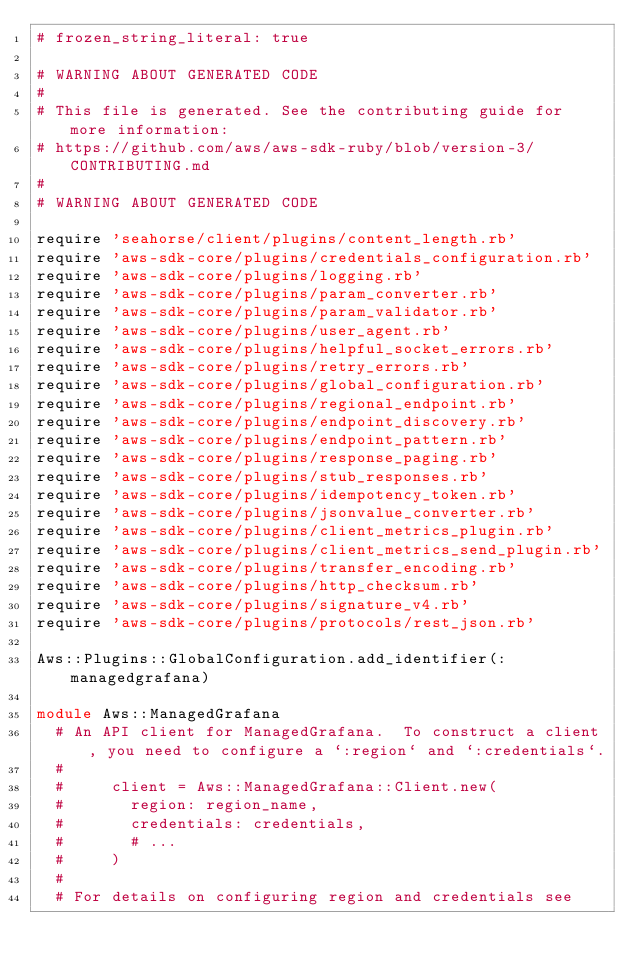Convert code to text. <code><loc_0><loc_0><loc_500><loc_500><_Ruby_># frozen_string_literal: true

# WARNING ABOUT GENERATED CODE
#
# This file is generated. See the contributing guide for more information:
# https://github.com/aws/aws-sdk-ruby/blob/version-3/CONTRIBUTING.md
#
# WARNING ABOUT GENERATED CODE

require 'seahorse/client/plugins/content_length.rb'
require 'aws-sdk-core/plugins/credentials_configuration.rb'
require 'aws-sdk-core/plugins/logging.rb'
require 'aws-sdk-core/plugins/param_converter.rb'
require 'aws-sdk-core/plugins/param_validator.rb'
require 'aws-sdk-core/plugins/user_agent.rb'
require 'aws-sdk-core/plugins/helpful_socket_errors.rb'
require 'aws-sdk-core/plugins/retry_errors.rb'
require 'aws-sdk-core/plugins/global_configuration.rb'
require 'aws-sdk-core/plugins/regional_endpoint.rb'
require 'aws-sdk-core/plugins/endpoint_discovery.rb'
require 'aws-sdk-core/plugins/endpoint_pattern.rb'
require 'aws-sdk-core/plugins/response_paging.rb'
require 'aws-sdk-core/plugins/stub_responses.rb'
require 'aws-sdk-core/plugins/idempotency_token.rb'
require 'aws-sdk-core/plugins/jsonvalue_converter.rb'
require 'aws-sdk-core/plugins/client_metrics_plugin.rb'
require 'aws-sdk-core/plugins/client_metrics_send_plugin.rb'
require 'aws-sdk-core/plugins/transfer_encoding.rb'
require 'aws-sdk-core/plugins/http_checksum.rb'
require 'aws-sdk-core/plugins/signature_v4.rb'
require 'aws-sdk-core/plugins/protocols/rest_json.rb'

Aws::Plugins::GlobalConfiguration.add_identifier(:managedgrafana)

module Aws::ManagedGrafana
  # An API client for ManagedGrafana.  To construct a client, you need to configure a `:region` and `:credentials`.
  #
  #     client = Aws::ManagedGrafana::Client.new(
  #       region: region_name,
  #       credentials: credentials,
  #       # ...
  #     )
  #
  # For details on configuring region and credentials see</code> 